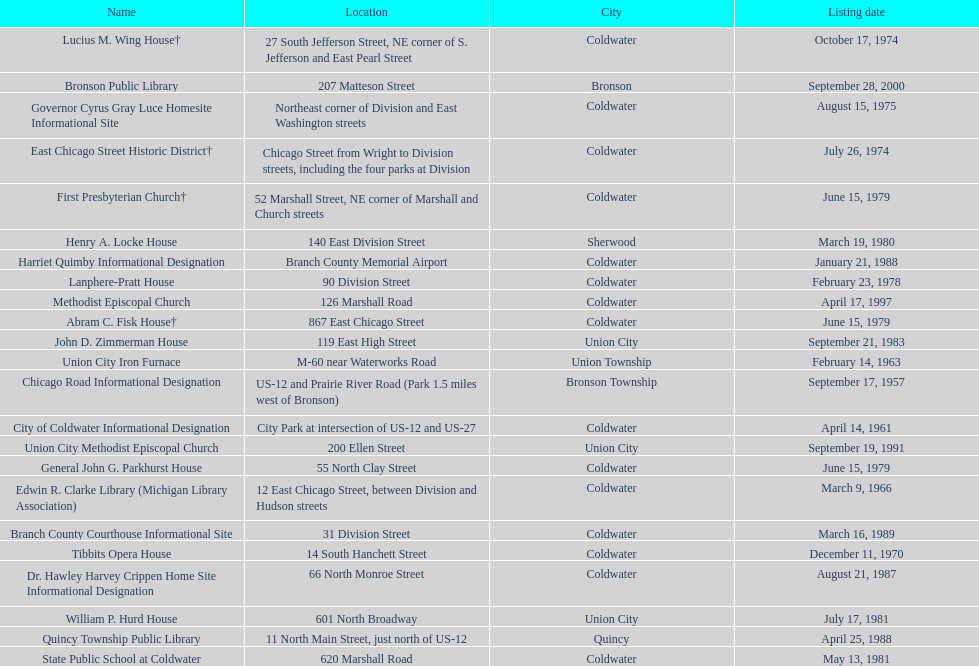Which site was listed earlier, the state public school or the edwin r. clarke library? Edwin R. Clarke Library. 